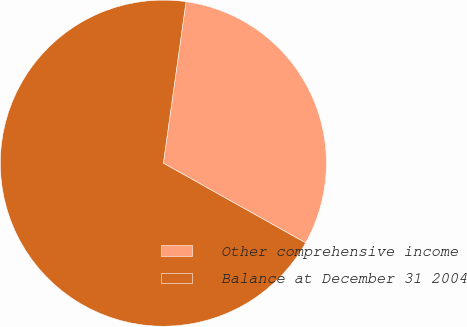<chart> <loc_0><loc_0><loc_500><loc_500><pie_chart><fcel>Other comprehensive income<fcel>Balance at December 31 2004<nl><fcel>30.91%<fcel>69.09%<nl></chart> 